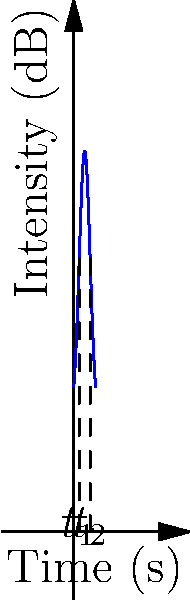In a study of tonal patterns in Mandarin Chinese, you're analyzing the intensity of a speaker's voice over time. The graph shows the intensity (in decibels) of a single syllable pronounced with a rising tone. Calculate the average intensity of the syllable between $t_1 = 1$ second and $t_2 = 3$ seconds. Use the function $I(t) = 50e^{-0.5(t-2)^2} + 20$ to model the intensity at time $t$. To find the average intensity, we need to calculate the area under the curve and divide it by the time interval. Let's approach this step-by-step:

1) The average intensity is given by:
   $$\text{Average Intensity} = \frac{1}{t_2 - t_1} \int_{t_1}^{t_2} I(t) dt$$

2) Substitute the function and limits:
   $$\frac{1}{3 - 1} \int_{1}^{3} (50e^{-0.5(t-2)^2} + 20) dt$$

3) Simplify:
   $$\frac{1}{2} \int_{1}^{3} (50e^{-0.5(t-2)^2} + 20) dt$$

4) Split the integral:
   $$\frac{1}{2} \left(\int_{1}^{3} 50e^{-0.5(t-2)^2} dt + \int_{1}^{3} 20 dt\right)$$

5) The second integral is straightforward:
   $$\frac{1}{2} \left(\int_{1}^{3} 50e^{-0.5(t-2)^2} dt + 40\right)$$

6) For the first integral, we need to use numerical integration (e.g., Simpson's rule or a computer algebra system) as it doesn't have a simple analytical solution.

7) Using numerical integration, we get:
   $$\int_{1}^{3} 50e^{-0.5(t-2)^2} dt \approx 89.6885$$

8) Substitute this back:
   $$\frac{1}{2} (89.6885 + 40) = \frac{129.6885}{2} = 64.8443$$

Therefore, the average intensity is approximately 64.84 dB.
Answer: 64.84 dB 